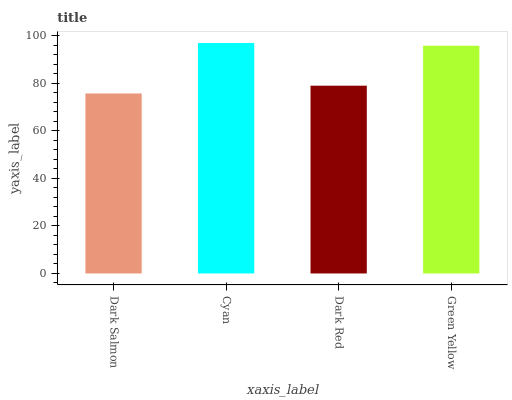Is Dark Salmon the minimum?
Answer yes or no. Yes. Is Cyan the maximum?
Answer yes or no. Yes. Is Dark Red the minimum?
Answer yes or no. No. Is Dark Red the maximum?
Answer yes or no. No. Is Cyan greater than Dark Red?
Answer yes or no. Yes. Is Dark Red less than Cyan?
Answer yes or no. Yes. Is Dark Red greater than Cyan?
Answer yes or no. No. Is Cyan less than Dark Red?
Answer yes or no. No. Is Green Yellow the high median?
Answer yes or no. Yes. Is Dark Red the low median?
Answer yes or no. Yes. Is Dark Salmon the high median?
Answer yes or no. No. Is Cyan the low median?
Answer yes or no. No. 